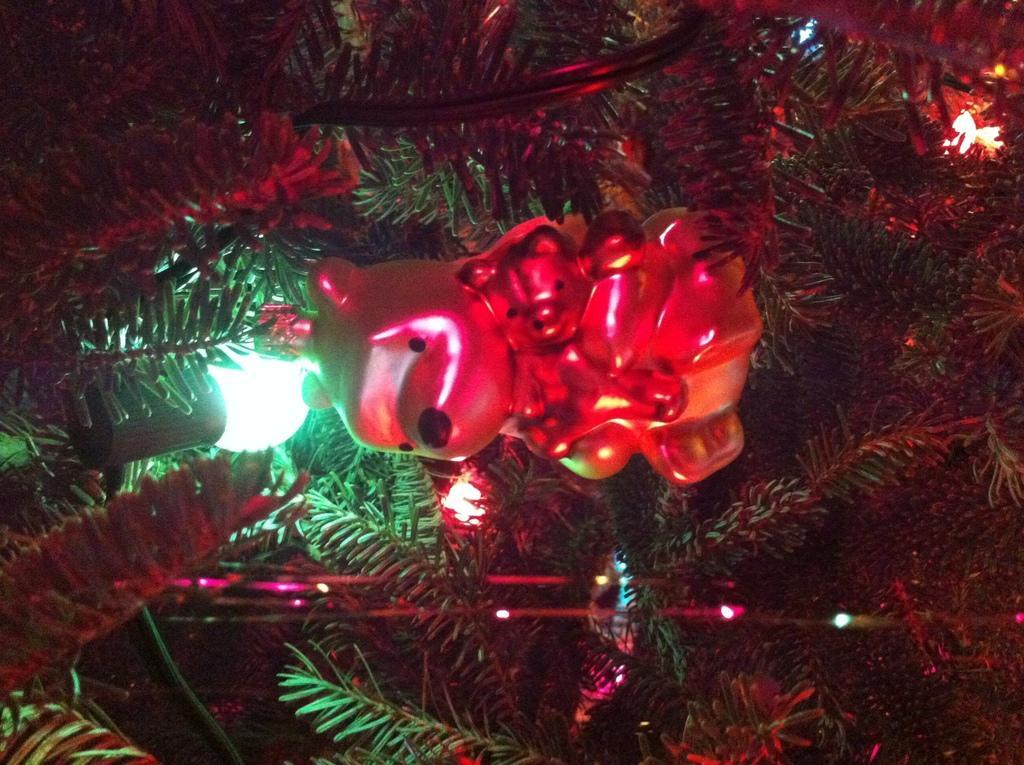Could you give a brief overview of what you see in this image? In this image we can see a toy is hanged to Christmas tree. 